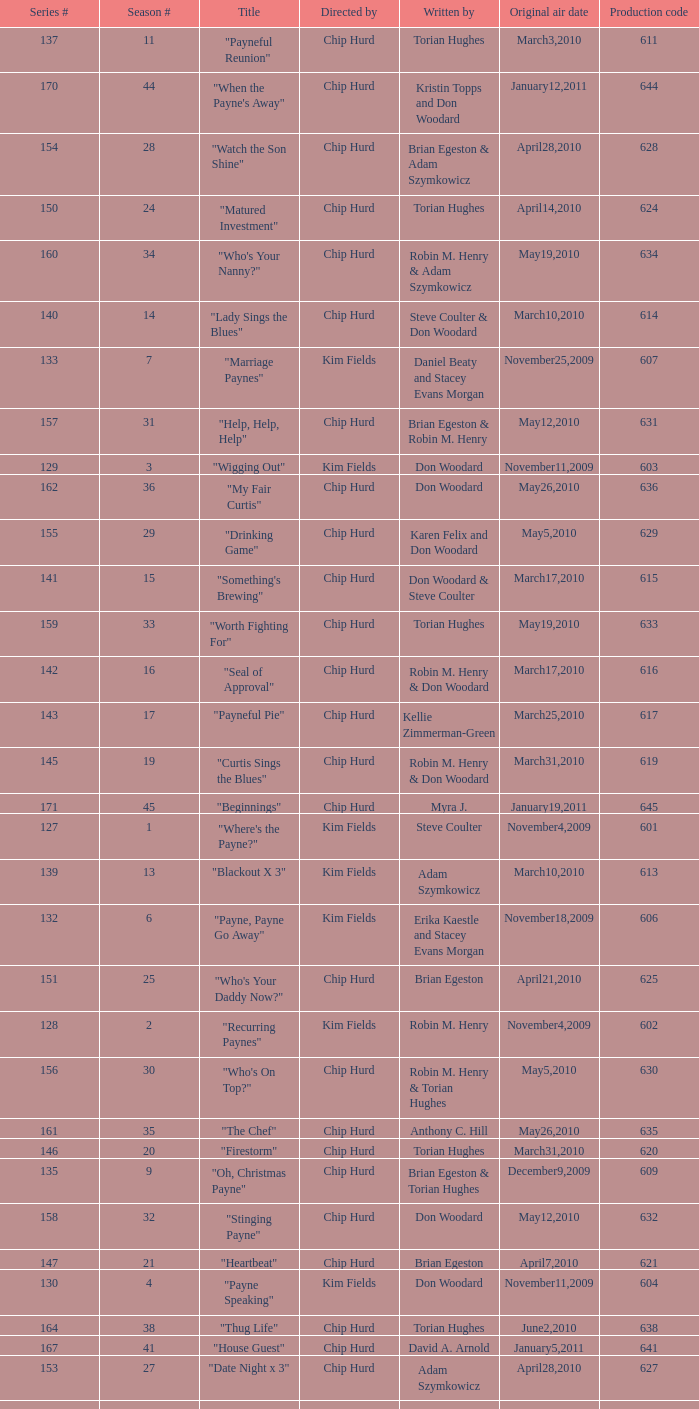What is the title of the episode with the production code 624? "Matured Investment". 